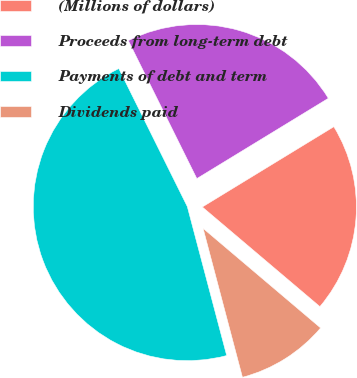Convert chart to OTSL. <chart><loc_0><loc_0><loc_500><loc_500><pie_chart><fcel>(Millions of dollars)<fcel>Proceeds from long-term debt<fcel>Payments of debt and term<fcel>Dividends paid<nl><fcel>19.91%<fcel>23.61%<fcel>46.78%<fcel>9.7%<nl></chart> 